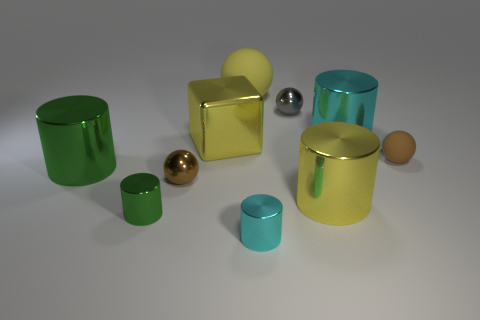What is the shape of the tiny cyan thing?
Provide a succinct answer. Cylinder. Are there any other things of the same color as the block?
Make the answer very short. Yes. How many large objects are both behind the large cyan shiny object and left of the large yellow rubber ball?
Your response must be concise. 0. Do the yellow metal thing to the right of the tiny cyan thing and the cyan cylinder to the left of the large cyan metallic cylinder have the same size?
Keep it short and to the point. No. What number of things are large metal objects that are left of the tiny brown metal object or metallic balls?
Your answer should be very brief. 3. There is a cyan thing behind the large yellow cylinder; what material is it?
Provide a succinct answer. Metal. What material is the large yellow sphere?
Ensure brevity in your answer.  Rubber. What is the material of the brown ball in front of the large object that is on the left side of the small brown sphere that is on the left side of the gray object?
Provide a short and direct response. Metal. Are there any other things that are the same material as the gray thing?
Ensure brevity in your answer.  Yes. Do the yellow block and the brown ball left of the gray metal sphere have the same size?
Offer a terse response. No. 